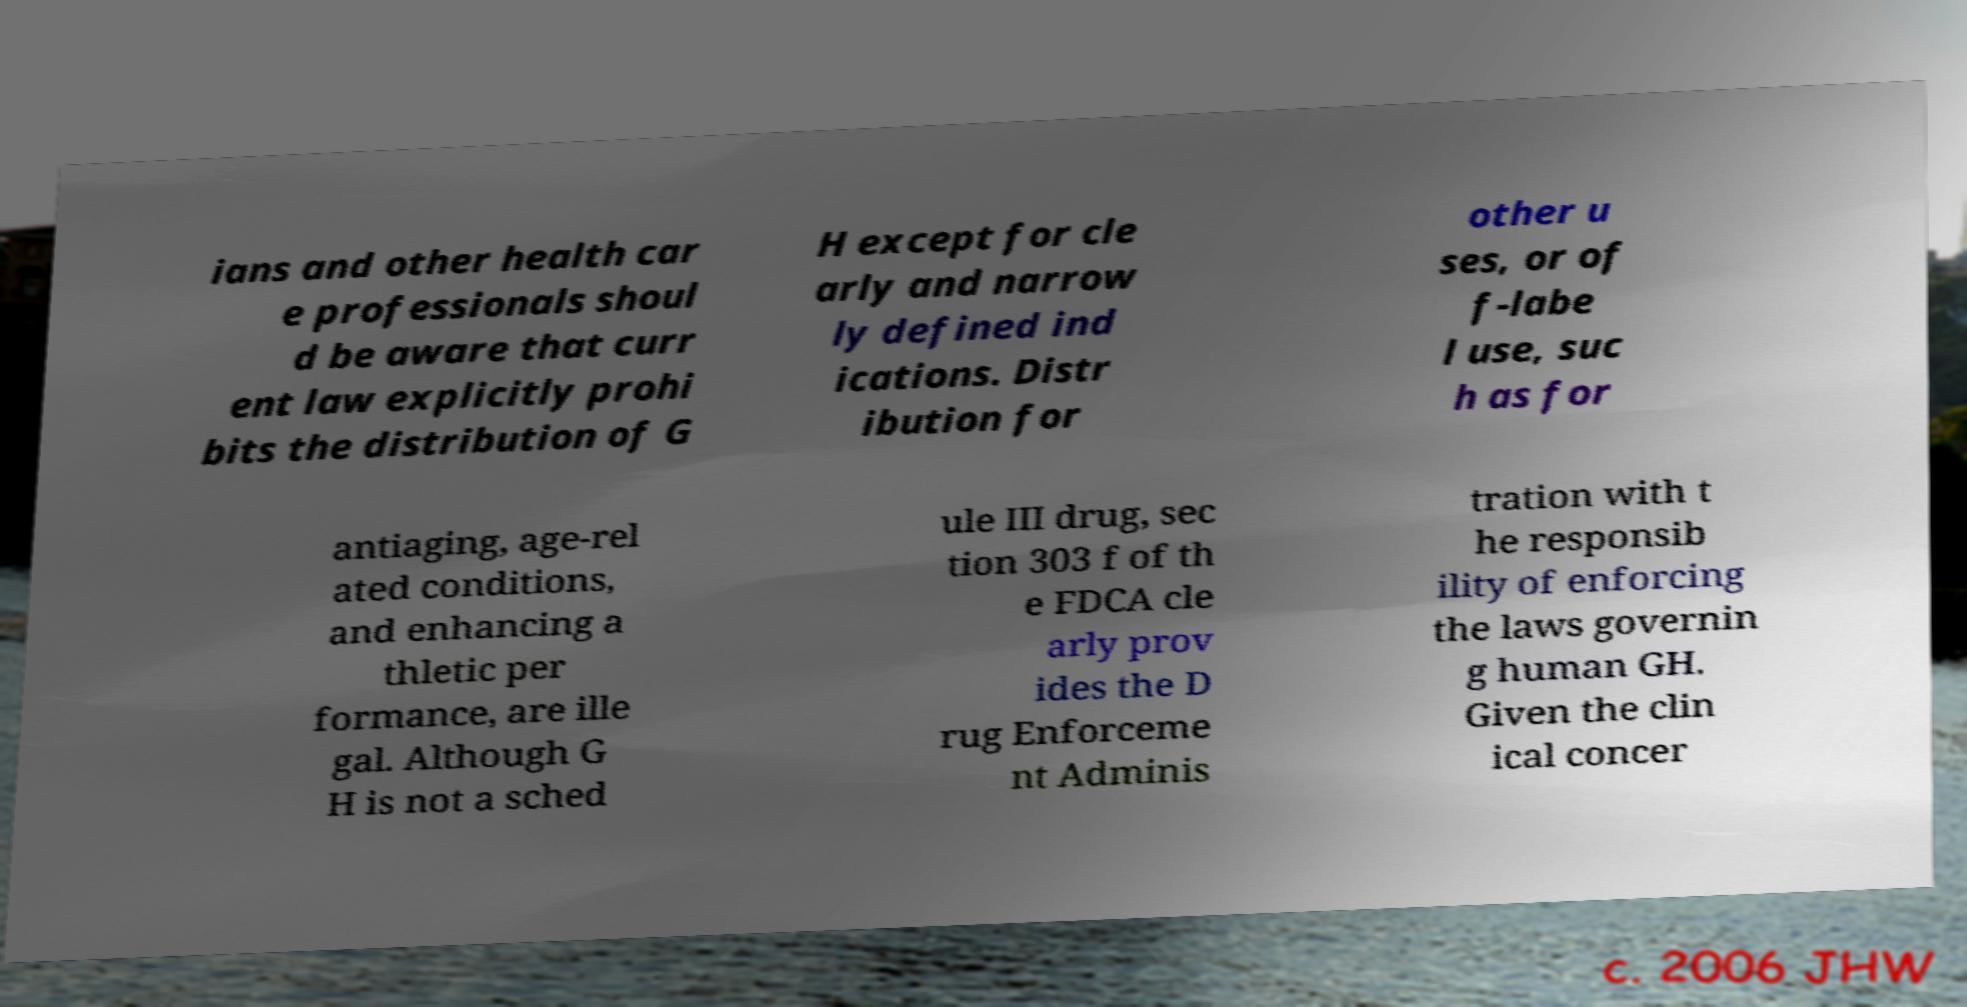Please read and relay the text visible in this image. What does it say? ians and other health car e professionals shoul d be aware that curr ent law explicitly prohi bits the distribution of G H except for cle arly and narrow ly defined ind ications. Distr ibution for other u ses, or of f-labe l use, suc h as for antiaging, age-rel ated conditions, and enhancing a thletic per formance, are ille gal. Although G H is not a sched ule III drug, sec tion 303 f of th e FDCA cle arly prov ides the D rug Enforceme nt Adminis tration with t he responsib ility of enforcing the laws governin g human GH. Given the clin ical concer 